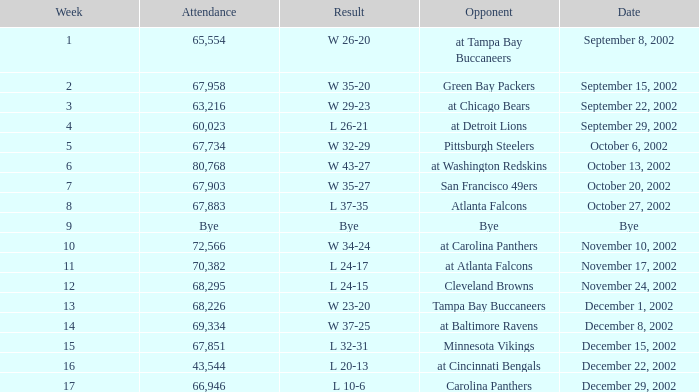Who was the opposing team in the game attended by 65,554? At tampa bay buccaneers. 